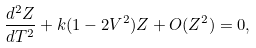Convert formula to latex. <formula><loc_0><loc_0><loc_500><loc_500>\frac { d ^ { 2 } Z } { d T ^ { 2 } } + k ( 1 - 2 V ^ { 2 } ) Z + O ( Z ^ { 2 } ) = 0 ,</formula> 